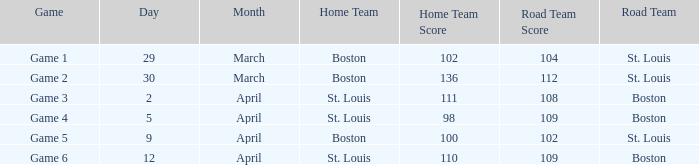What Game had a Result of 136-112? Game 2. 